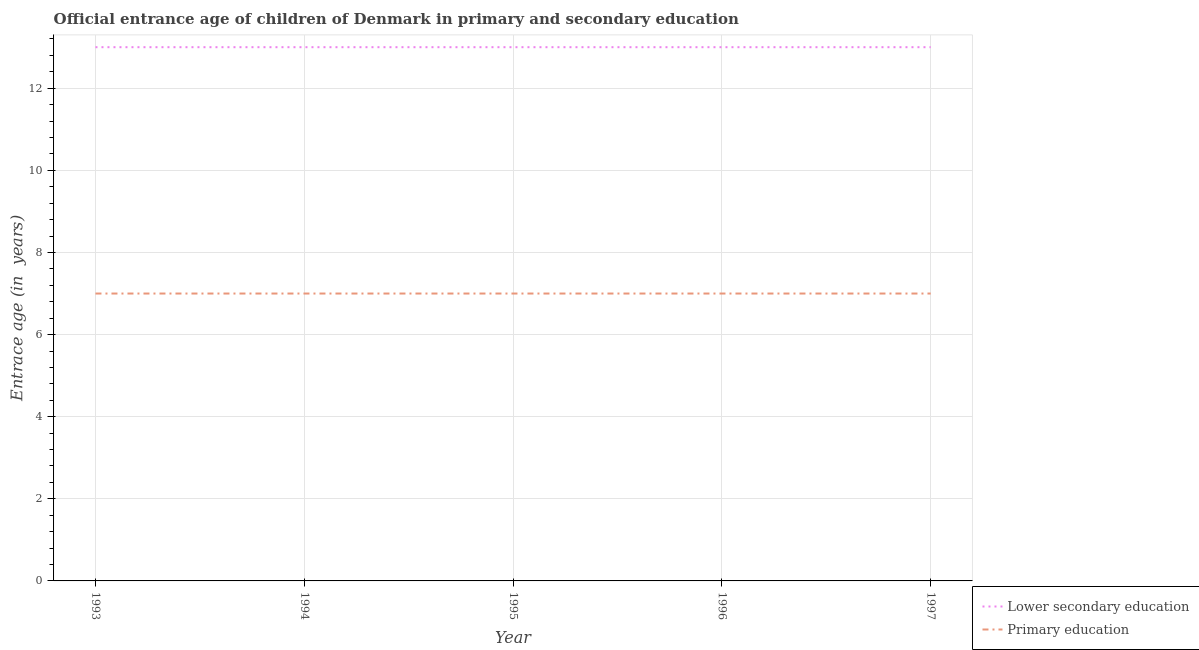How many different coloured lines are there?
Provide a short and direct response. 2. Does the line corresponding to entrance age of chiildren in primary education intersect with the line corresponding to entrance age of children in lower secondary education?
Keep it short and to the point. No. What is the entrance age of children in lower secondary education in 1993?
Your response must be concise. 13. Across all years, what is the maximum entrance age of chiildren in primary education?
Your response must be concise. 7. Across all years, what is the minimum entrance age of chiildren in primary education?
Your answer should be compact. 7. In which year was the entrance age of chiildren in primary education maximum?
Ensure brevity in your answer.  1993. In which year was the entrance age of chiildren in primary education minimum?
Offer a terse response. 1993. What is the total entrance age of chiildren in primary education in the graph?
Offer a terse response. 35. What is the difference between the entrance age of chiildren in primary education in 1996 and the entrance age of children in lower secondary education in 1997?
Ensure brevity in your answer.  -6. What is the average entrance age of children in lower secondary education per year?
Keep it short and to the point. 13. In the year 1996, what is the difference between the entrance age of children in lower secondary education and entrance age of chiildren in primary education?
Your response must be concise. 6. What is the ratio of the entrance age of children in lower secondary education in 1994 to that in 1996?
Your answer should be very brief. 1. Is the entrance age of chiildren in primary education in 1993 less than that in 1995?
Give a very brief answer. No. What is the difference between the highest and the lowest entrance age of children in lower secondary education?
Your answer should be very brief. 0. Does the entrance age of chiildren in primary education monotonically increase over the years?
Ensure brevity in your answer.  No. Is the entrance age of children in lower secondary education strictly greater than the entrance age of chiildren in primary education over the years?
Keep it short and to the point. Yes. How many years are there in the graph?
Your response must be concise. 5. Does the graph contain any zero values?
Your answer should be very brief. No. Where does the legend appear in the graph?
Make the answer very short. Bottom right. How many legend labels are there?
Make the answer very short. 2. What is the title of the graph?
Give a very brief answer. Official entrance age of children of Denmark in primary and secondary education. Does "Merchandise exports" appear as one of the legend labels in the graph?
Keep it short and to the point. No. What is the label or title of the X-axis?
Provide a short and direct response. Year. What is the label or title of the Y-axis?
Your response must be concise. Entrace age (in  years). What is the Entrace age (in  years) of Primary education in 1994?
Provide a short and direct response. 7. What is the Entrace age (in  years) of Primary education in 1995?
Your response must be concise. 7. What is the Entrace age (in  years) in Primary education in 1996?
Offer a very short reply. 7. Across all years, what is the maximum Entrace age (in  years) in Lower secondary education?
Keep it short and to the point. 13. Across all years, what is the maximum Entrace age (in  years) of Primary education?
Offer a terse response. 7. Across all years, what is the minimum Entrace age (in  years) of Lower secondary education?
Give a very brief answer. 13. What is the difference between the Entrace age (in  years) of Lower secondary education in 1993 and that in 1994?
Give a very brief answer. 0. What is the difference between the Entrace age (in  years) of Primary education in 1993 and that in 1994?
Ensure brevity in your answer.  0. What is the difference between the Entrace age (in  years) of Lower secondary education in 1993 and that in 1995?
Ensure brevity in your answer.  0. What is the difference between the Entrace age (in  years) of Primary education in 1993 and that in 1997?
Give a very brief answer. 0. What is the difference between the Entrace age (in  years) of Lower secondary education in 1994 and that in 1995?
Provide a short and direct response. 0. What is the difference between the Entrace age (in  years) in Primary education in 1994 and that in 1995?
Give a very brief answer. 0. What is the difference between the Entrace age (in  years) in Primary education in 1994 and that in 1996?
Keep it short and to the point. 0. What is the difference between the Entrace age (in  years) of Lower secondary education in 1995 and that in 1996?
Ensure brevity in your answer.  0. What is the difference between the Entrace age (in  years) of Lower secondary education in 1995 and that in 1997?
Your response must be concise. 0. What is the difference between the Entrace age (in  years) of Primary education in 1995 and that in 1997?
Your response must be concise. 0. What is the difference between the Entrace age (in  years) in Primary education in 1996 and that in 1997?
Your answer should be very brief. 0. What is the difference between the Entrace age (in  years) of Lower secondary education in 1993 and the Entrace age (in  years) of Primary education in 1994?
Your answer should be compact. 6. What is the difference between the Entrace age (in  years) in Lower secondary education in 1993 and the Entrace age (in  years) in Primary education in 1995?
Offer a terse response. 6. What is the difference between the Entrace age (in  years) of Lower secondary education in 1993 and the Entrace age (in  years) of Primary education in 1997?
Offer a very short reply. 6. What is the difference between the Entrace age (in  years) in Lower secondary education in 1994 and the Entrace age (in  years) in Primary education in 1995?
Make the answer very short. 6. What is the difference between the Entrace age (in  years) in Lower secondary education in 1994 and the Entrace age (in  years) in Primary education in 1996?
Offer a very short reply. 6. What is the difference between the Entrace age (in  years) in Lower secondary education in 1995 and the Entrace age (in  years) in Primary education in 1996?
Ensure brevity in your answer.  6. What is the difference between the Entrace age (in  years) of Lower secondary education in 1995 and the Entrace age (in  years) of Primary education in 1997?
Provide a short and direct response. 6. What is the difference between the Entrace age (in  years) of Lower secondary education in 1996 and the Entrace age (in  years) of Primary education in 1997?
Give a very brief answer. 6. In the year 1993, what is the difference between the Entrace age (in  years) of Lower secondary education and Entrace age (in  years) of Primary education?
Provide a short and direct response. 6. In the year 1996, what is the difference between the Entrace age (in  years) in Lower secondary education and Entrace age (in  years) in Primary education?
Your answer should be very brief. 6. In the year 1997, what is the difference between the Entrace age (in  years) of Lower secondary education and Entrace age (in  years) of Primary education?
Your response must be concise. 6. What is the ratio of the Entrace age (in  years) of Lower secondary education in 1993 to that in 1994?
Provide a short and direct response. 1. What is the ratio of the Entrace age (in  years) in Primary education in 1993 to that in 1995?
Provide a short and direct response. 1. What is the ratio of the Entrace age (in  years) in Primary education in 1993 to that in 1996?
Your answer should be compact. 1. What is the ratio of the Entrace age (in  years) in Primary education in 1993 to that in 1997?
Your answer should be very brief. 1. What is the ratio of the Entrace age (in  years) of Lower secondary education in 1994 to that in 1995?
Provide a succinct answer. 1. What is the ratio of the Entrace age (in  years) of Primary education in 1994 to that in 1995?
Your answer should be very brief. 1. What is the ratio of the Entrace age (in  years) in Primary education in 1994 to that in 1996?
Your response must be concise. 1. What is the ratio of the Entrace age (in  years) in Lower secondary education in 1995 to that in 1996?
Provide a short and direct response. 1. What is the ratio of the Entrace age (in  years) of Primary education in 1995 to that in 1996?
Provide a short and direct response. 1. What is the ratio of the Entrace age (in  years) of Primary education in 1995 to that in 1997?
Your answer should be very brief. 1. What is the ratio of the Entrace age (in  years) in Primary education in 1996 to that in 1997?
Give a very brief answer. 1. What is the difference between the highest and the second highest Entrace age (in  years) of Lower secondary education?
Your answer should be very brief. 0. What is the difference between the highest and the second highest Entrace age (in  years) of Primary education?
Your response must be concise. 0. What is the difference between the highest and the lowest Entrace age (in  years) of Lower secondary education?
Make the answer very short. 0. What is the difference between the highest and the lowest Entrace age (in  years) in Primary education?
Offer a terse response. 0. 